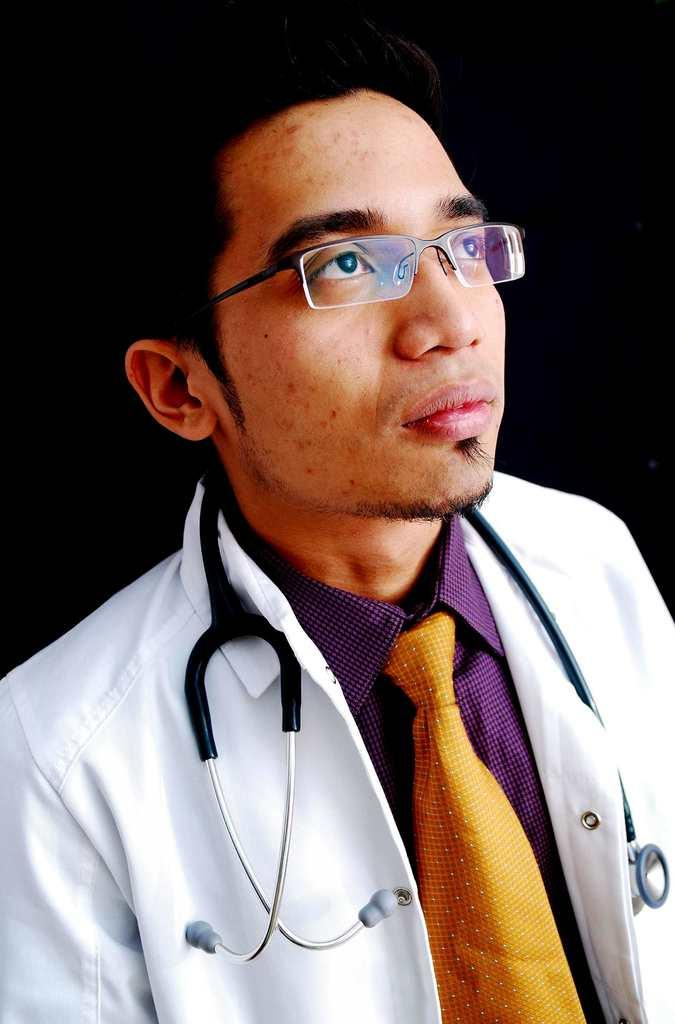What is the main subject of the picture? The main subject of the picture is a man. What is the man wearing on his upper body? The man is wearing a shirt, a tie, and an apron. What is the man wearing around his neck? The man is wearing a stethoscope around his neck. What is the man wearing on his face? The man is wearing spectacles. What can be observed about the background of the image? The background of the image appears to be dark. What type of condition is the tree branch in the image? There is no tree branch present in the image. What is the current flowing through the man's body in the image? There is no indication of a current flowing through the man's body in the image. 